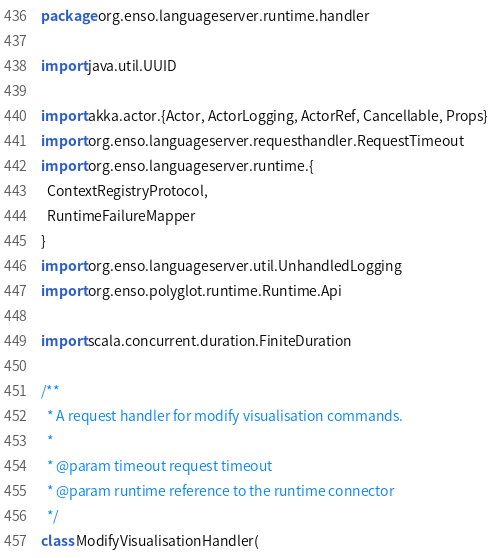<code> <loc_0><loc_0><loc_500><loc_500><_Scala_>package org.enso.languageserver.runtime.handler

import java.util.UUID

import akka.actor.{Actor, ActorLogging, ActorRef, Cancellable, Props}
import org.enso.languageserver.requesthandler.RequestTimeout
import org.enso.languageserver.runtime.{
  ContextRegistryProtocol,
  RuntimeFailureMapper
}
import org.enso.languageserver.util.UnhandledLogging
import org.enso.polyglot.runtime.Runtime.Api

import scala.concurrent.duration.FiniteDuration

/**
  * A request handler for modify visualisation commands.
  *
  * @param timeout request timeout
  * @param runtime reference to the runtime connector
  */
class ModifyVisualisationHandler(</code> 